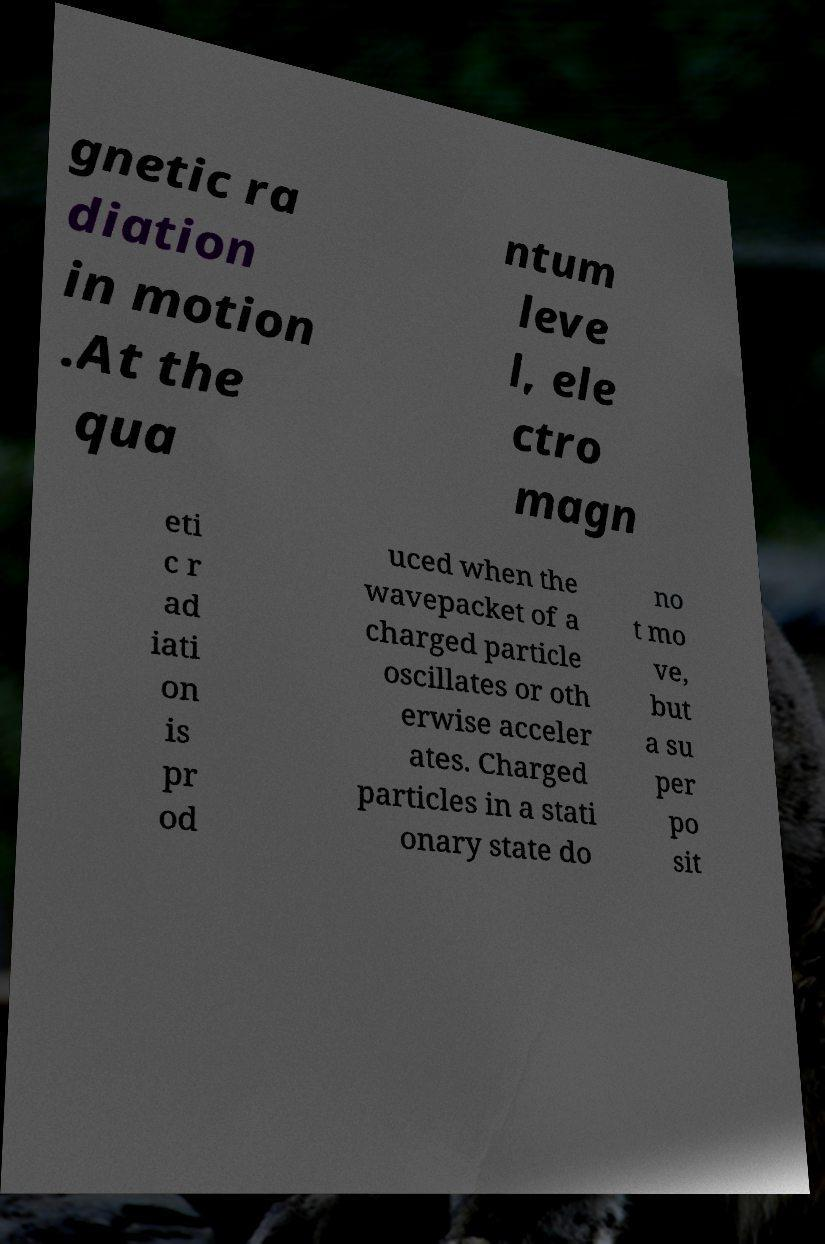What messages or text are displayed in this image? I need them in a readable, typed format. gnetic ra diation in motion .At the qua ntum leve l, ele ctro magn eti c r ad iati on is pr od uced when the wavepacket of a charged particle oscillates or oth erwise acceler ates. Charged particles in a stati onary state do no t mo ve, but a su per po sit 